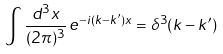<formula> <loc_0><loc_0><loc_500><loc_500>\int \frac { d ^ { 3 } x } { ( 2 \pi ) ^ { 3 } } \, e ^ { - i ( { k } - { k } ^ { \prime } ) { x } } = \delta ^ { 3 } ( { k } - { k } ^ { \prime } )</formula> 